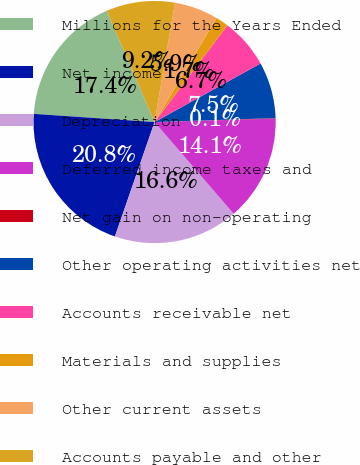Convert chart. <chart><loc_0><loc_0><loc_500><loc_500><pie_chart><fcel>Millions for the Years Ended<fcel>Net income<fcel>Depreciation<fcel>Deferred income taxes and<fcel>Net gain on non-operating<fcel>Other operating activities net<fcel>Accounts receivable net<fcel>Materials and supplies<fcel>Other current assets<fcel>Accounts payable and other<nl><fcel>17.45%<fcel>20.77%<fcel>16.63%<fcel>14.14%<fcel>0.06%<fcel>7.52%<fcel>6.69%<fcel>1.72%<fcel>5.86%<fcel>9.17%<nl></chart> 